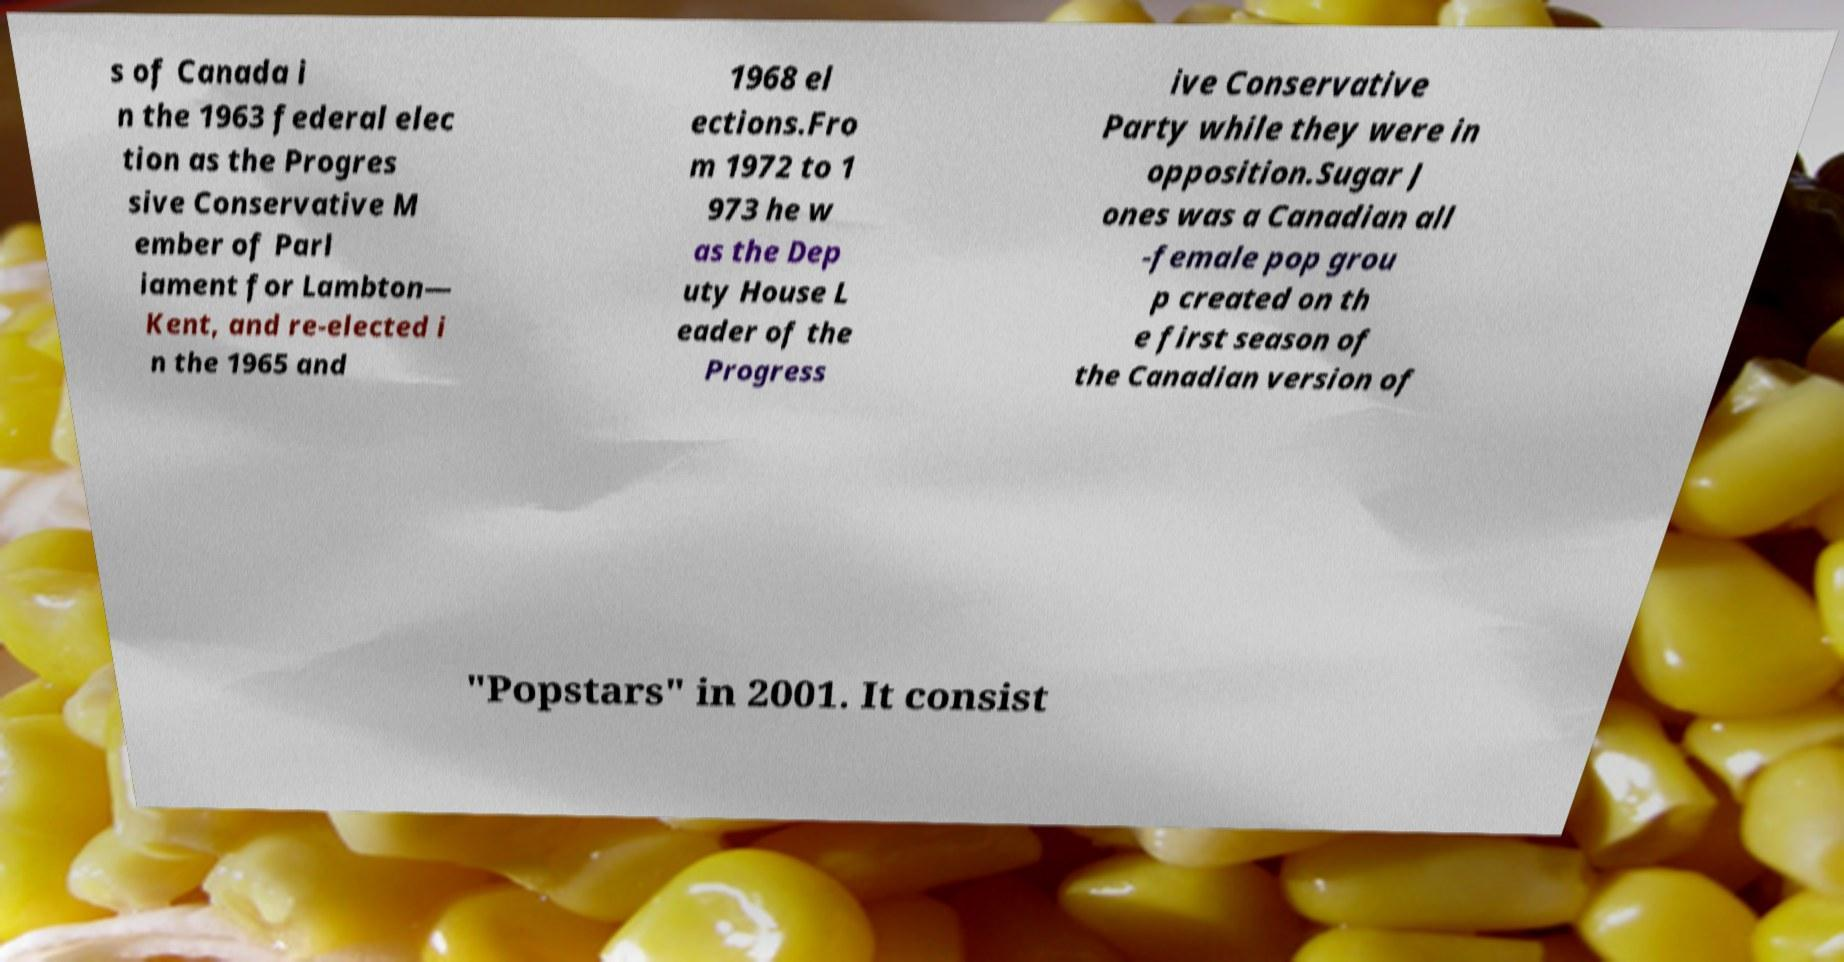Could you extract and type out the text from this image? s of Canada i n the 1963 federal elec tion as the Progres sive Conservative M ember of Parl iament for Lambton— Kent, and re-elected i n the 1965 and 1968 el ections.Fro m 1972 to 1 973 he w as the Dep uty House L eader of the Progress ive Conservative Party while they were in opposition.Sugar J ones was a Canadian all -female pop grou p created on th e first season of the Canadian version of "Popstars" in 2001. It consist 